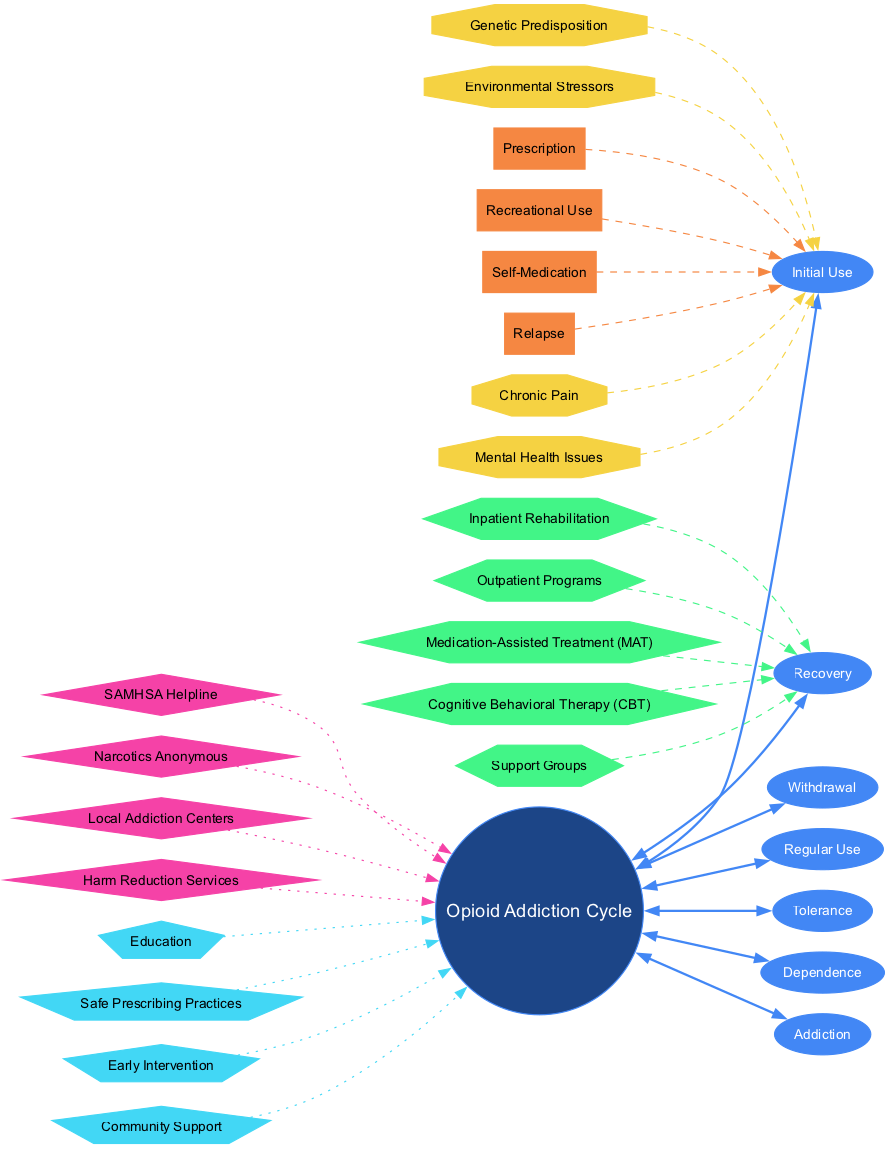What are the stages of opioid addiction? The stages are listed around the central node labeled "Opioid Addiction Cycle." They include Initial Use, Regular Use, Tolerance, Dependence, Addiction, Withdrawal, and Recovery.
Answer: Initial Use, Regular Use, Tolerance, Dependence, Addiction, Withdrawal, Recovery How many treatment options are shown? There are five treatment options displayed at the edge of the "Recovery" stage, each represented by a hexagon node that connects to the recovery stage.
Answer: 5 Which pathway is connected to Initial Use? The pathways connected to Initial Use are Prescription, Recreational Use, and Self-Medication. Each pathway links to the "Initial Use" stage with a dashed line.
Answer: Prescription, Recreational Use, Self-Medication What color are the risk factors nodes? The risk factors are depicted in the diagram as octagons, which are filled with the color yellow, specifically represented as '#f5d242'.
Answer: Yellow Which treatment option is shown as part of Medication-Assisted Treatment? The treatment options connected to the "Recovery" stage, specifically associated with Medication-Assisted Treatment, include various forms of therapy. However, none are specifically labeled as only Medication-Assisted Treatment. Further context would be needed to specify if one treatment directly reflects that category.
Answer: Not specified If a person is in the "Addiction" stage, what is the next possible stage they might reach? The diagram shows that the next possible state from "Addiction" can lead directly to "Withdrawal," as indicated by the circular flow of the diagram.
Answer: Withdrawal What are two resources listed for recovery? The resources connected to the central node highlight options for support, including SAMHSA Helpline and Narcotics Anonymous. These are indicated by their diamond-shaped nodes, which connect back to the center.
Answer: SAMHSA Helpline, Narcotics Anonymous How many prevention methods are illustrated in the diagram? The prevention methods are represented by five nodes, shown as pentagons connecting back to the central circle, which addresses preventative measures related to opioid addiction.
Answer: 4 